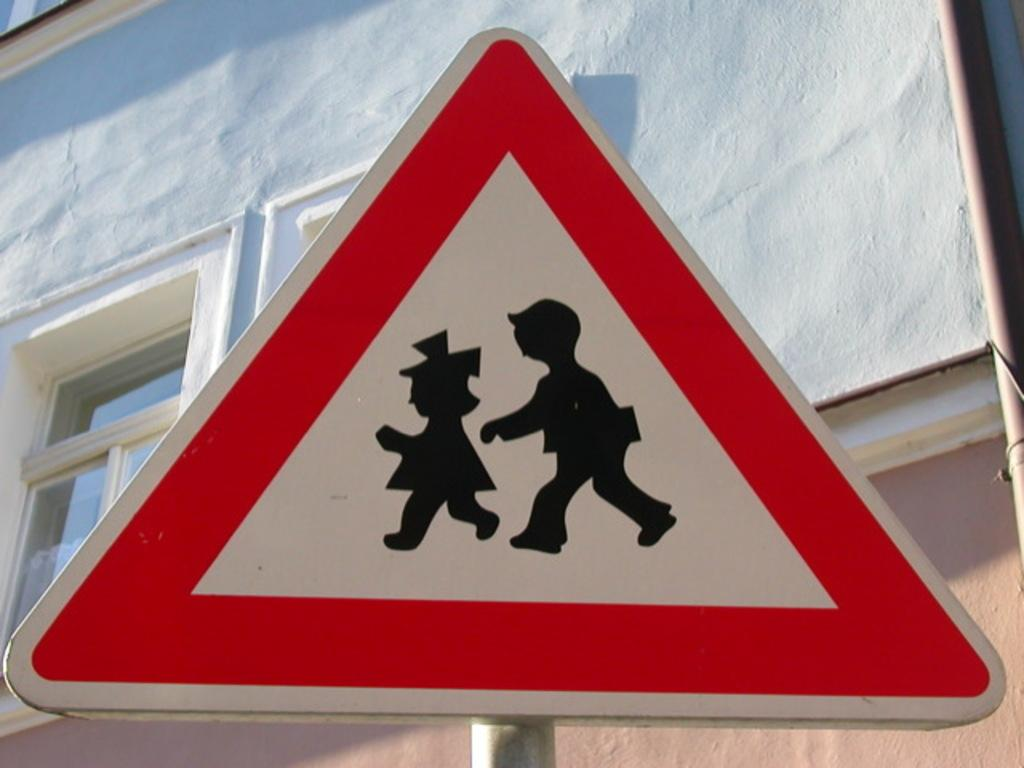What is located on a pole in the image? There is a sign board on a pole in the image. What can be seen in the background of the image? There is a building visible in the background of the image. How many birds are sitting on the bed in the image? There are no birds or beds present in the image. 